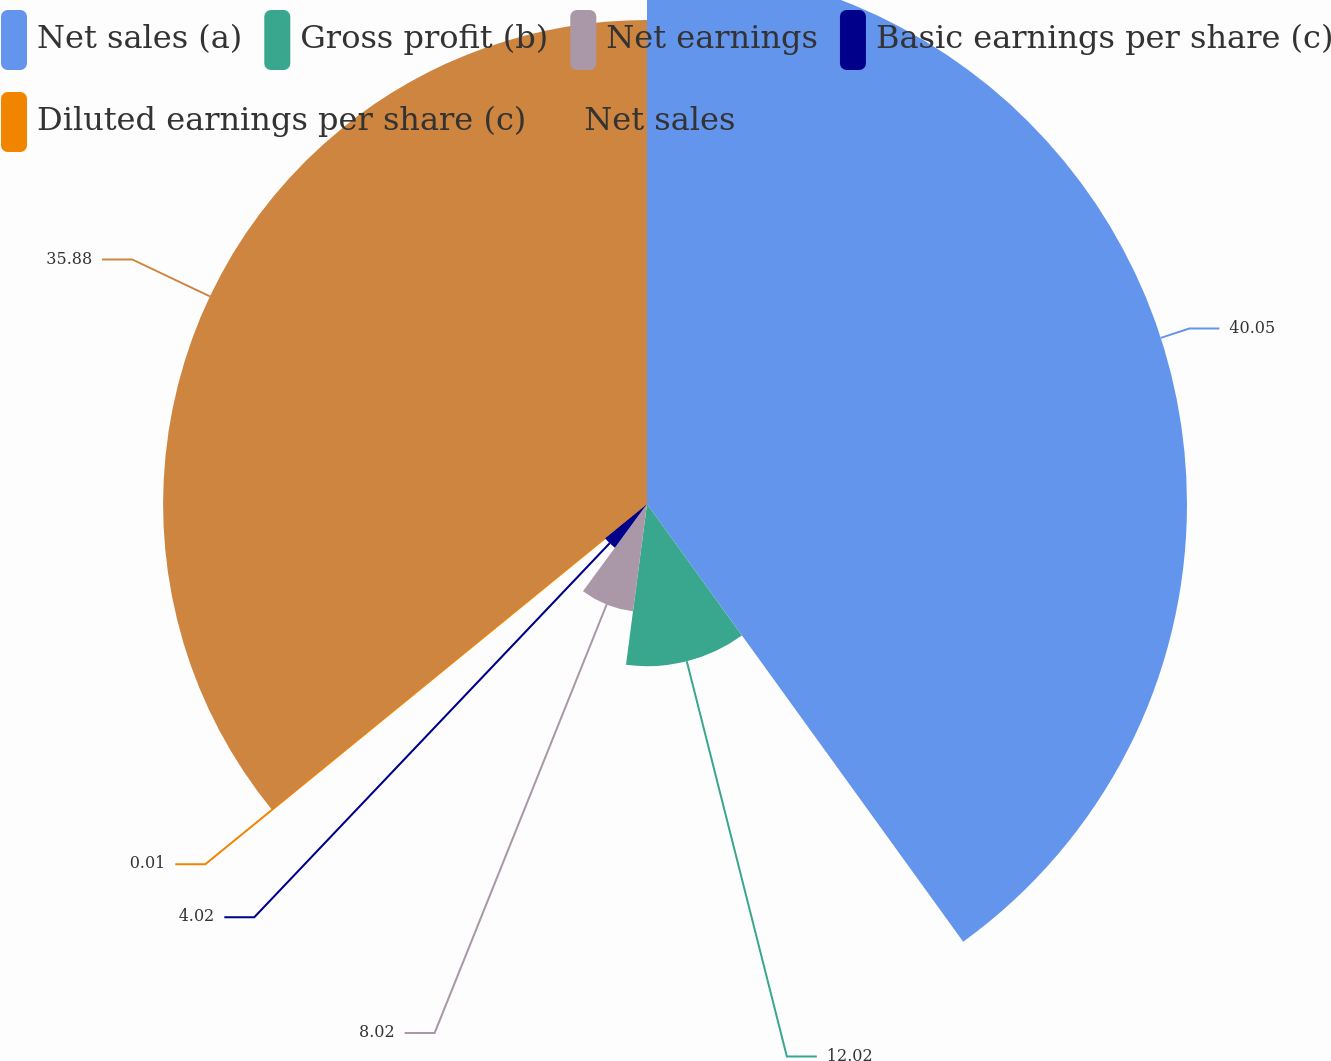<chart> <loc_0><loc_0><loc_500><loc_500><pie_chart><fcel>Net sales (a)<fcel>Gross profit (b)<fcel>Net earnings<fcel>Basic earnings per share (c)<fcel>Diluted earnings per share (c)<fcel>Net sales<nl><fcel>40.04%<fcel>12.02%<fcel>8.02%<fcel>4.02%<fcel>0.01%<fcel>35.88%<nl></chart> 